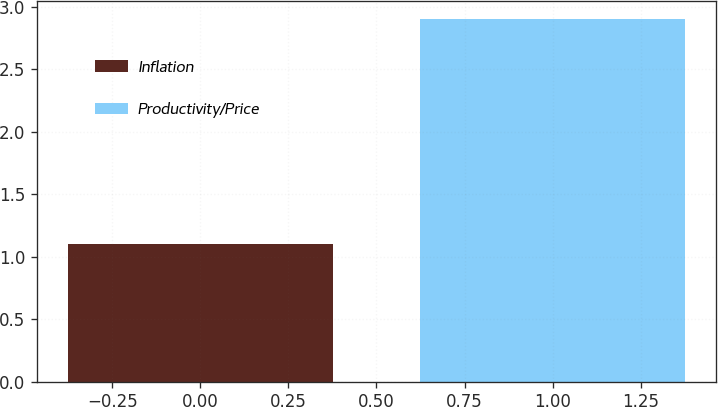Convert chart. <chart><loc_0><loc_0><loc_500><loc_500><bar_chart><fcel>Inflation<fcel>Productivity/Price<nl><fcel>1.1<fcel>2.9<nl></chart> 